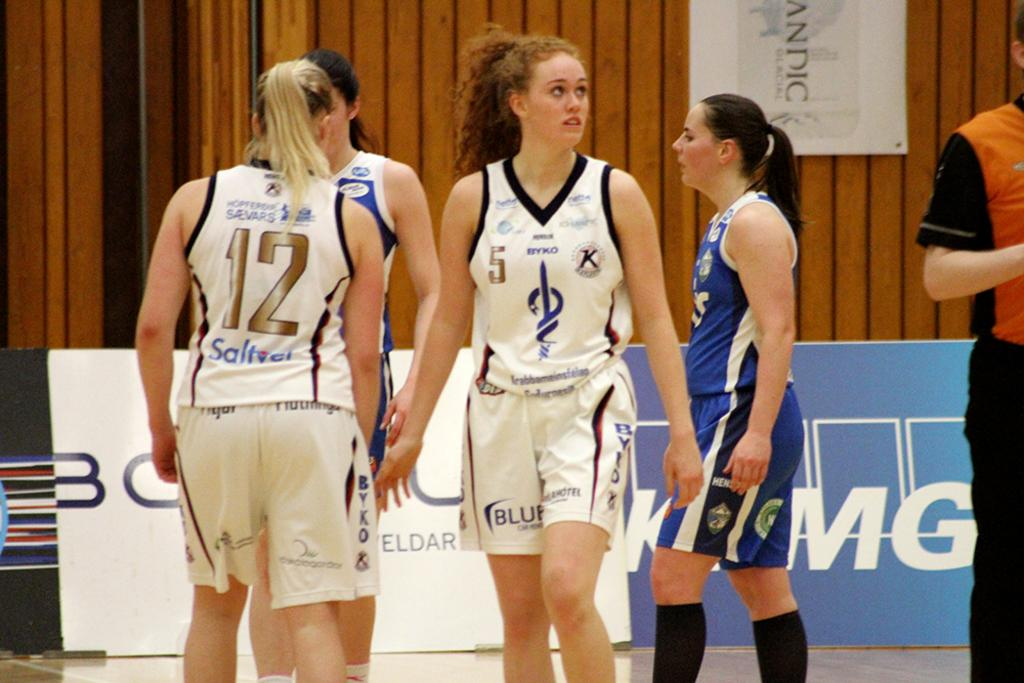Provide a one-sentence caption for the provided image. Women playing basketball in white jerseys with the word BYKO on them. 